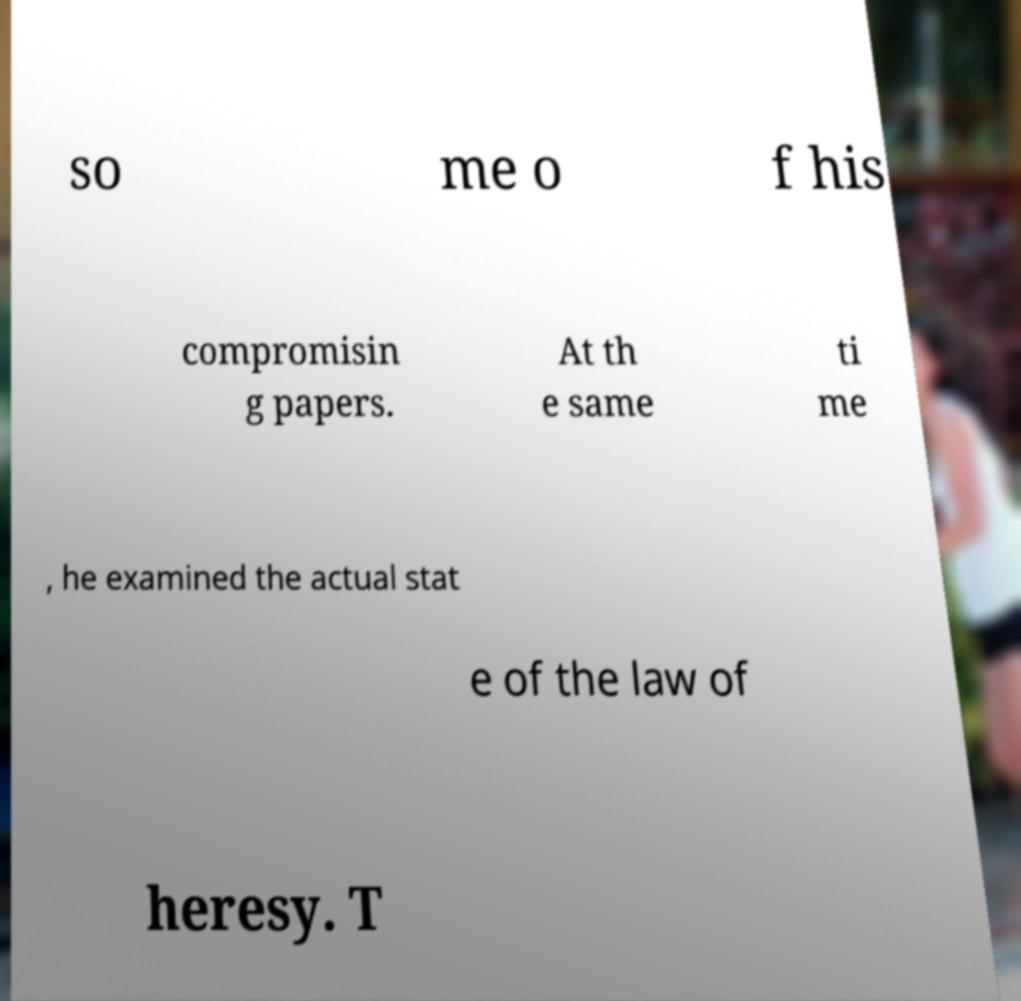What messages or text are displayed in this image? I need them in a readable, typed format. so me o f his compromisin g papers. At th e same ti me , he examined the actual stat e of the law of heresy. T 